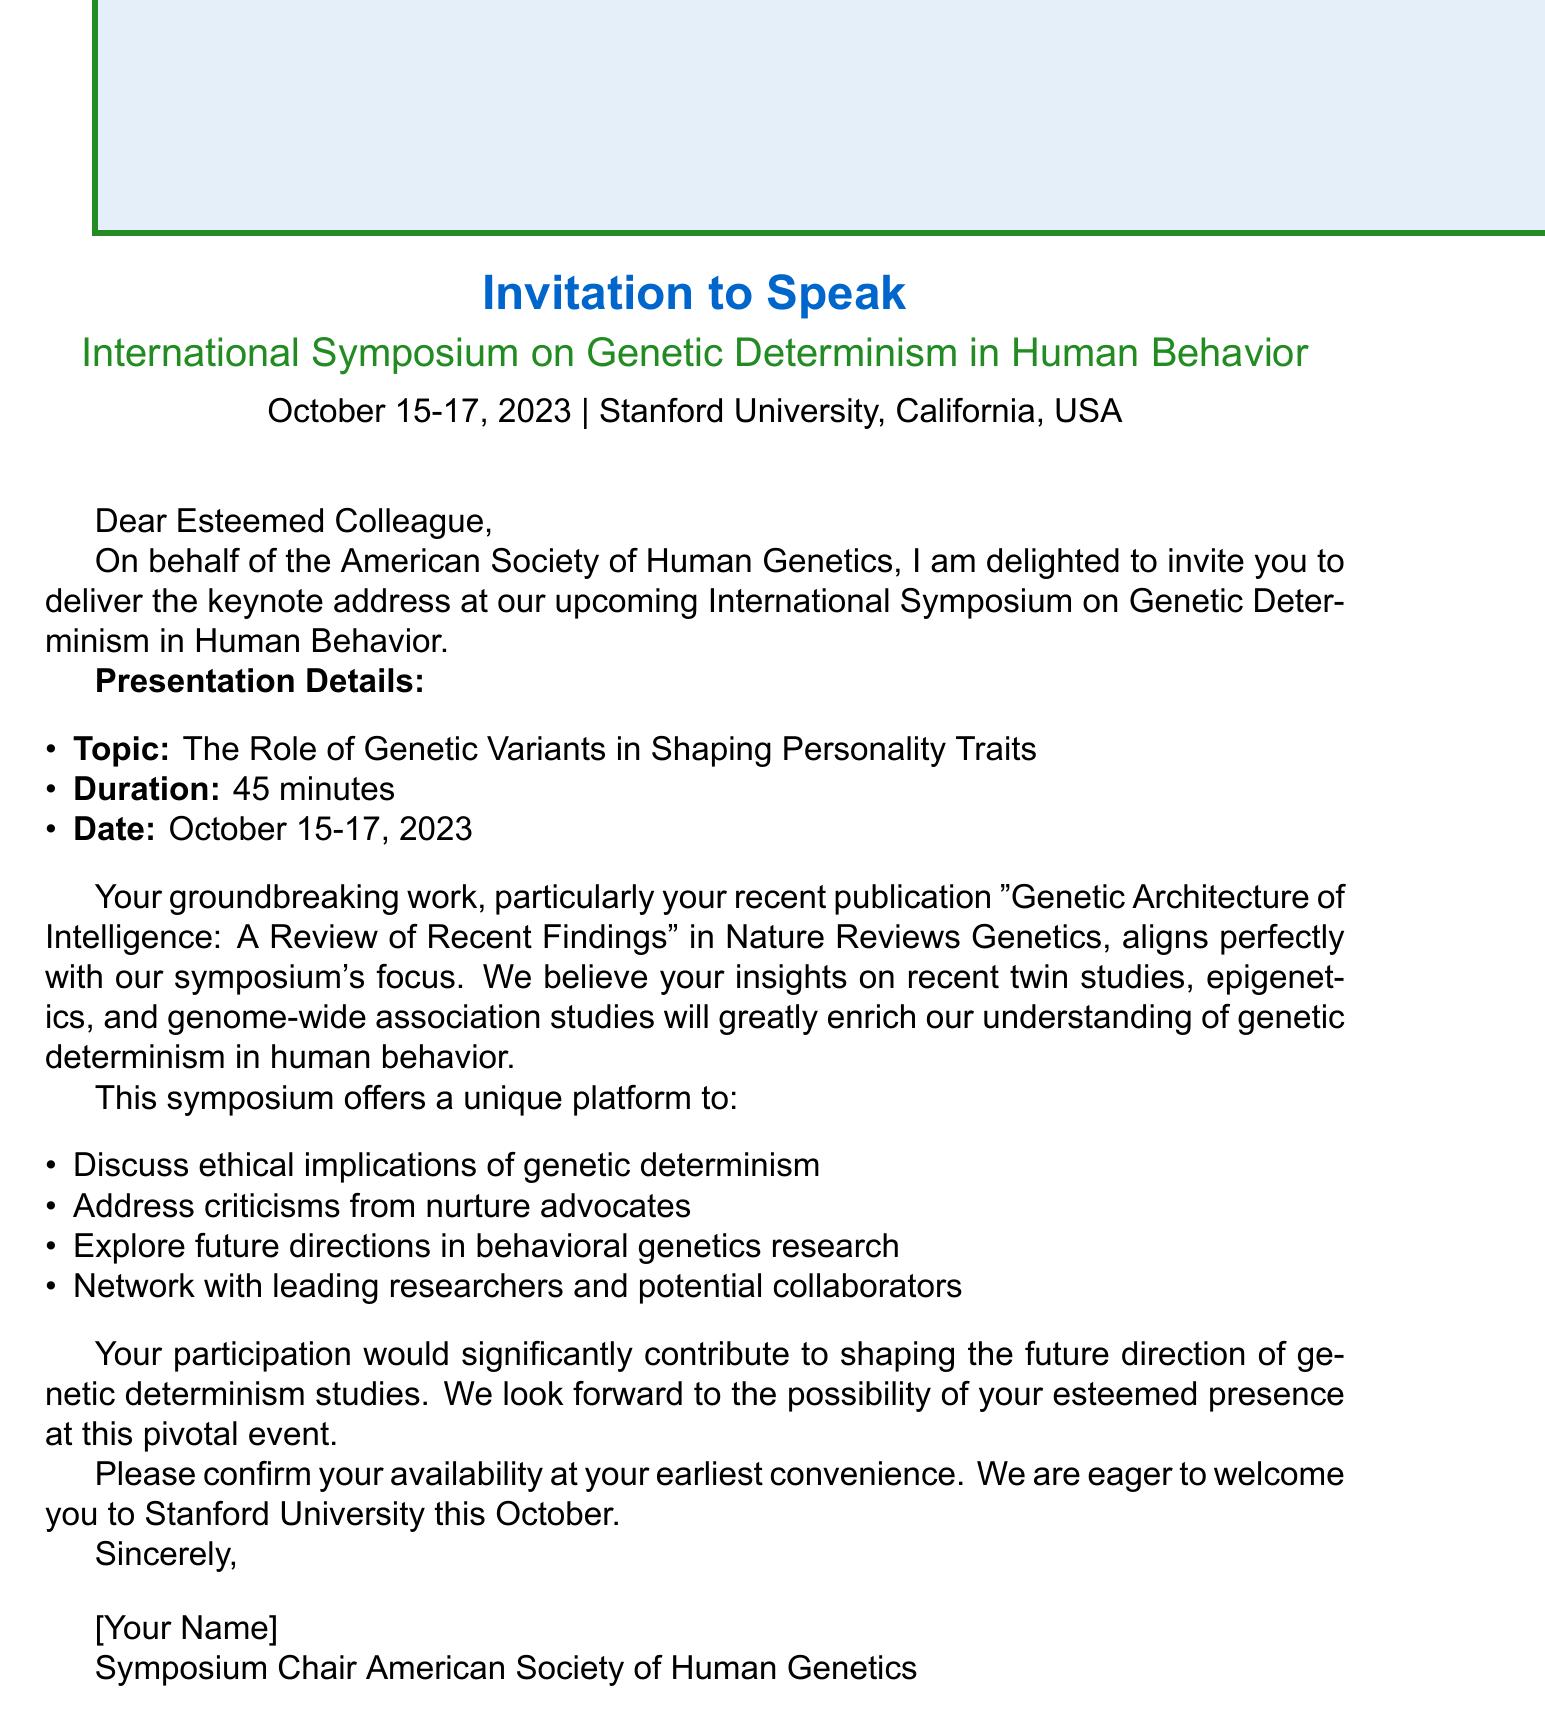What is the name of the conference? The name of the conference is mentioned in the opening of the document.
Answer: International Symposium on Genetic Determinism in Human Behavior What are the conference dates? The dates for the conference are provided in the initial section.
Answer: October 15-17, 2023 Who is the organizer of the symposium? The organization responsible for the event is specified in the document.
Answer: American Society of Human Genetics What is the presentation duration? The duration for the keynote address is listed under presentation details.
Answer: 45 minutes What is the topic suggestion for the keynote address? The suggested topic for the speaker is highlighted in the presentation details.
Answer: The Role of Genetic Variants in Shaping Personality Traits Which journal published the relevant publication mentioned? The publication's journal is indicated in the list of relevant publications.
Answer: Nature Reviews Genetics List one potential discussion point mentioned in the document. The document includes several potential discussion points for the conference.
Answer: Ethical implications of genetic determinism in behavior What is one networking opportunity available at the conference? The networking opportunities offered at the conference are specified in the document.
Answer: Meet leading researchers in behavioral genetics What is the expected impact of the conference? The document states the impact of the symposium in a single phrase.
Answer: Platform to influence the direction of future genetic determinism studies 